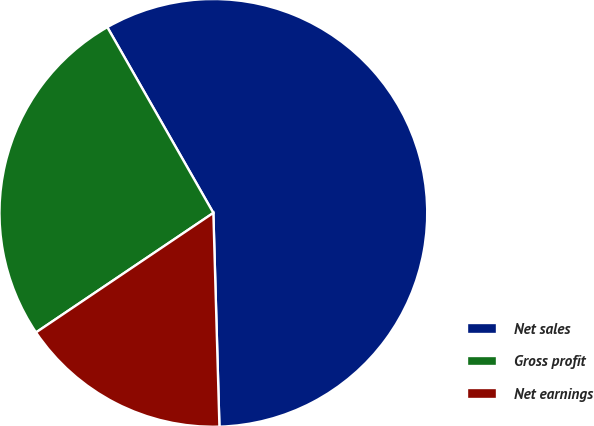Convert chart to OTSL. <chart><loc_0><loc_0><loc_500><loc_500><pie_chart><fcel>Net sales<fcel>Gross profit<fcel>Net earnings<nl><fcel>57.8%<fcel>26.18%<fcel>16.01%<nl></chart> 